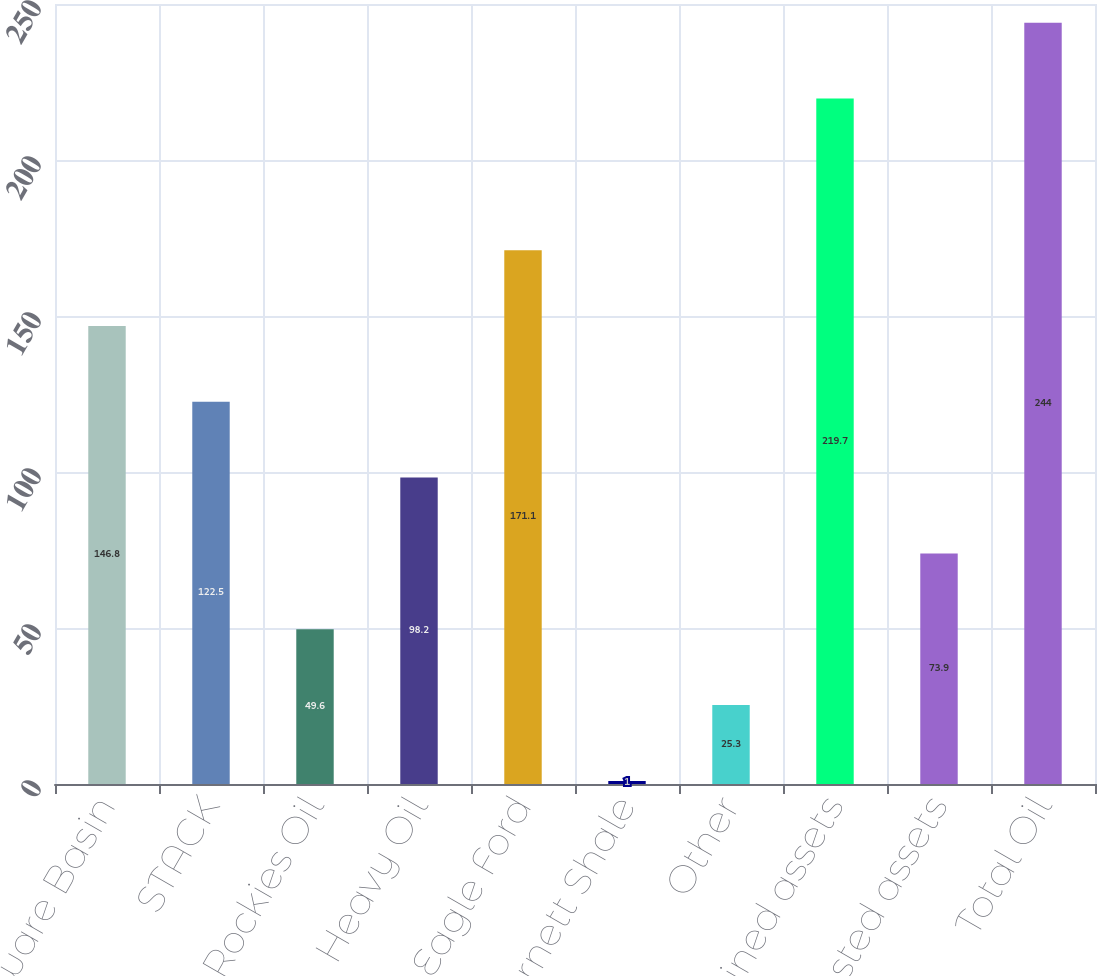Convert chart. <chart><loc_0><loc_0><loc_500><loc_500><bar_chart><fcel>Delaware Basin<fcel>STACK<fcel>Rockies Oil<fcel>Heavy Oil<fcel>Eagle Ford<fcel>Barnett Shale<fcel>Other<fcel>Retained assets<fcel>US divested assets<fcel>Total Oil<nl><fcel>146.8<fcel>122.5<fcel>49.6<fcel>98.2<fcel>171.1<fcel>1<fcel>25.3<fcel>219.7<fcel>73.9<fcel>244<nl></chart> 